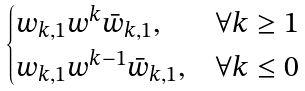<formula> <loc_0><loc_0><loc_500><loc_500>\begin{cases} w _ { k , 1 } w ^ { k } \bar { w } _ { k , 1 } , & \forall k \geq 1 \\ w _ { k , 1 } w ^ { k - 1 } \bar { w } _ { k , 1 } , & \forall k \leq 0 \end{cases}</formula> 